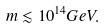Convert formula to latex. <formula><loc_0><loc_0><loc_500><loc_500>m \lesssim 1 0 ^ { 1 4 } G e V .</formula> 